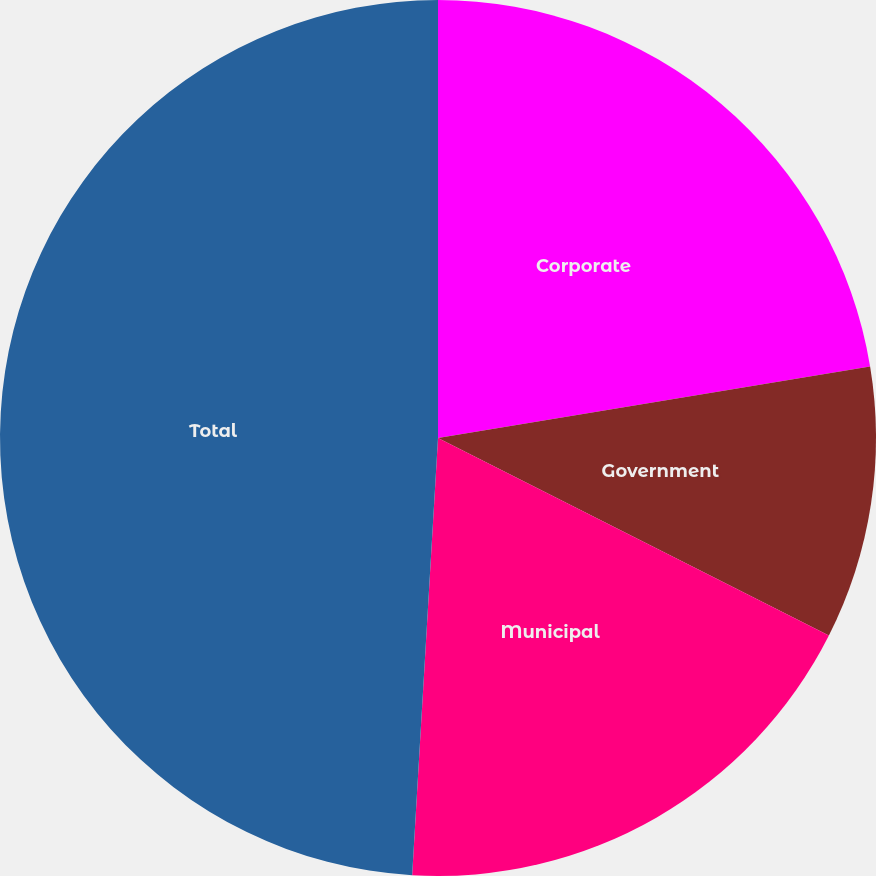Convert chart to OTSL. <chart><loc_0><loc_0><loc_500><loc_500><pie_chart><fcel>Corporate<fcel>Government<fcel>Municipal<fcel>Total<nl><fcel>22.39%<fcel>10.06%<fcel>18.49%<fcel>49.06%<nl></chart> 